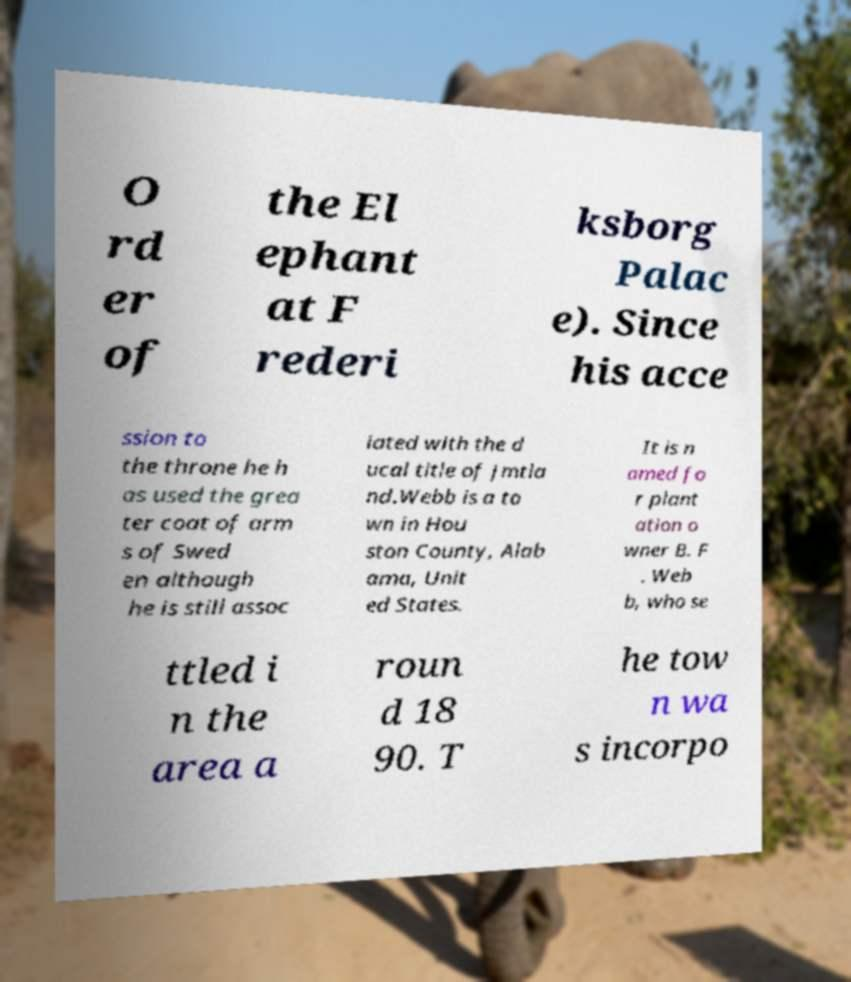Could you assist in decoding the text presented in this image and type it out clearly? O rd er of the El ephant at F rederi ksborg Palac e). Since his acce ssion to the throne he h as used the grea ter coat of arm s of Swed en although he is still assoc iated with the d ucal title of Jmtla nd.Webb is a to wn in Hou ston County, Alab ama, Unit ed States. It is n amed fo r plant ation o wner B. F . Web b, who se ttled i n the area a roun d 18 90. T he tow n wa s incorpo 